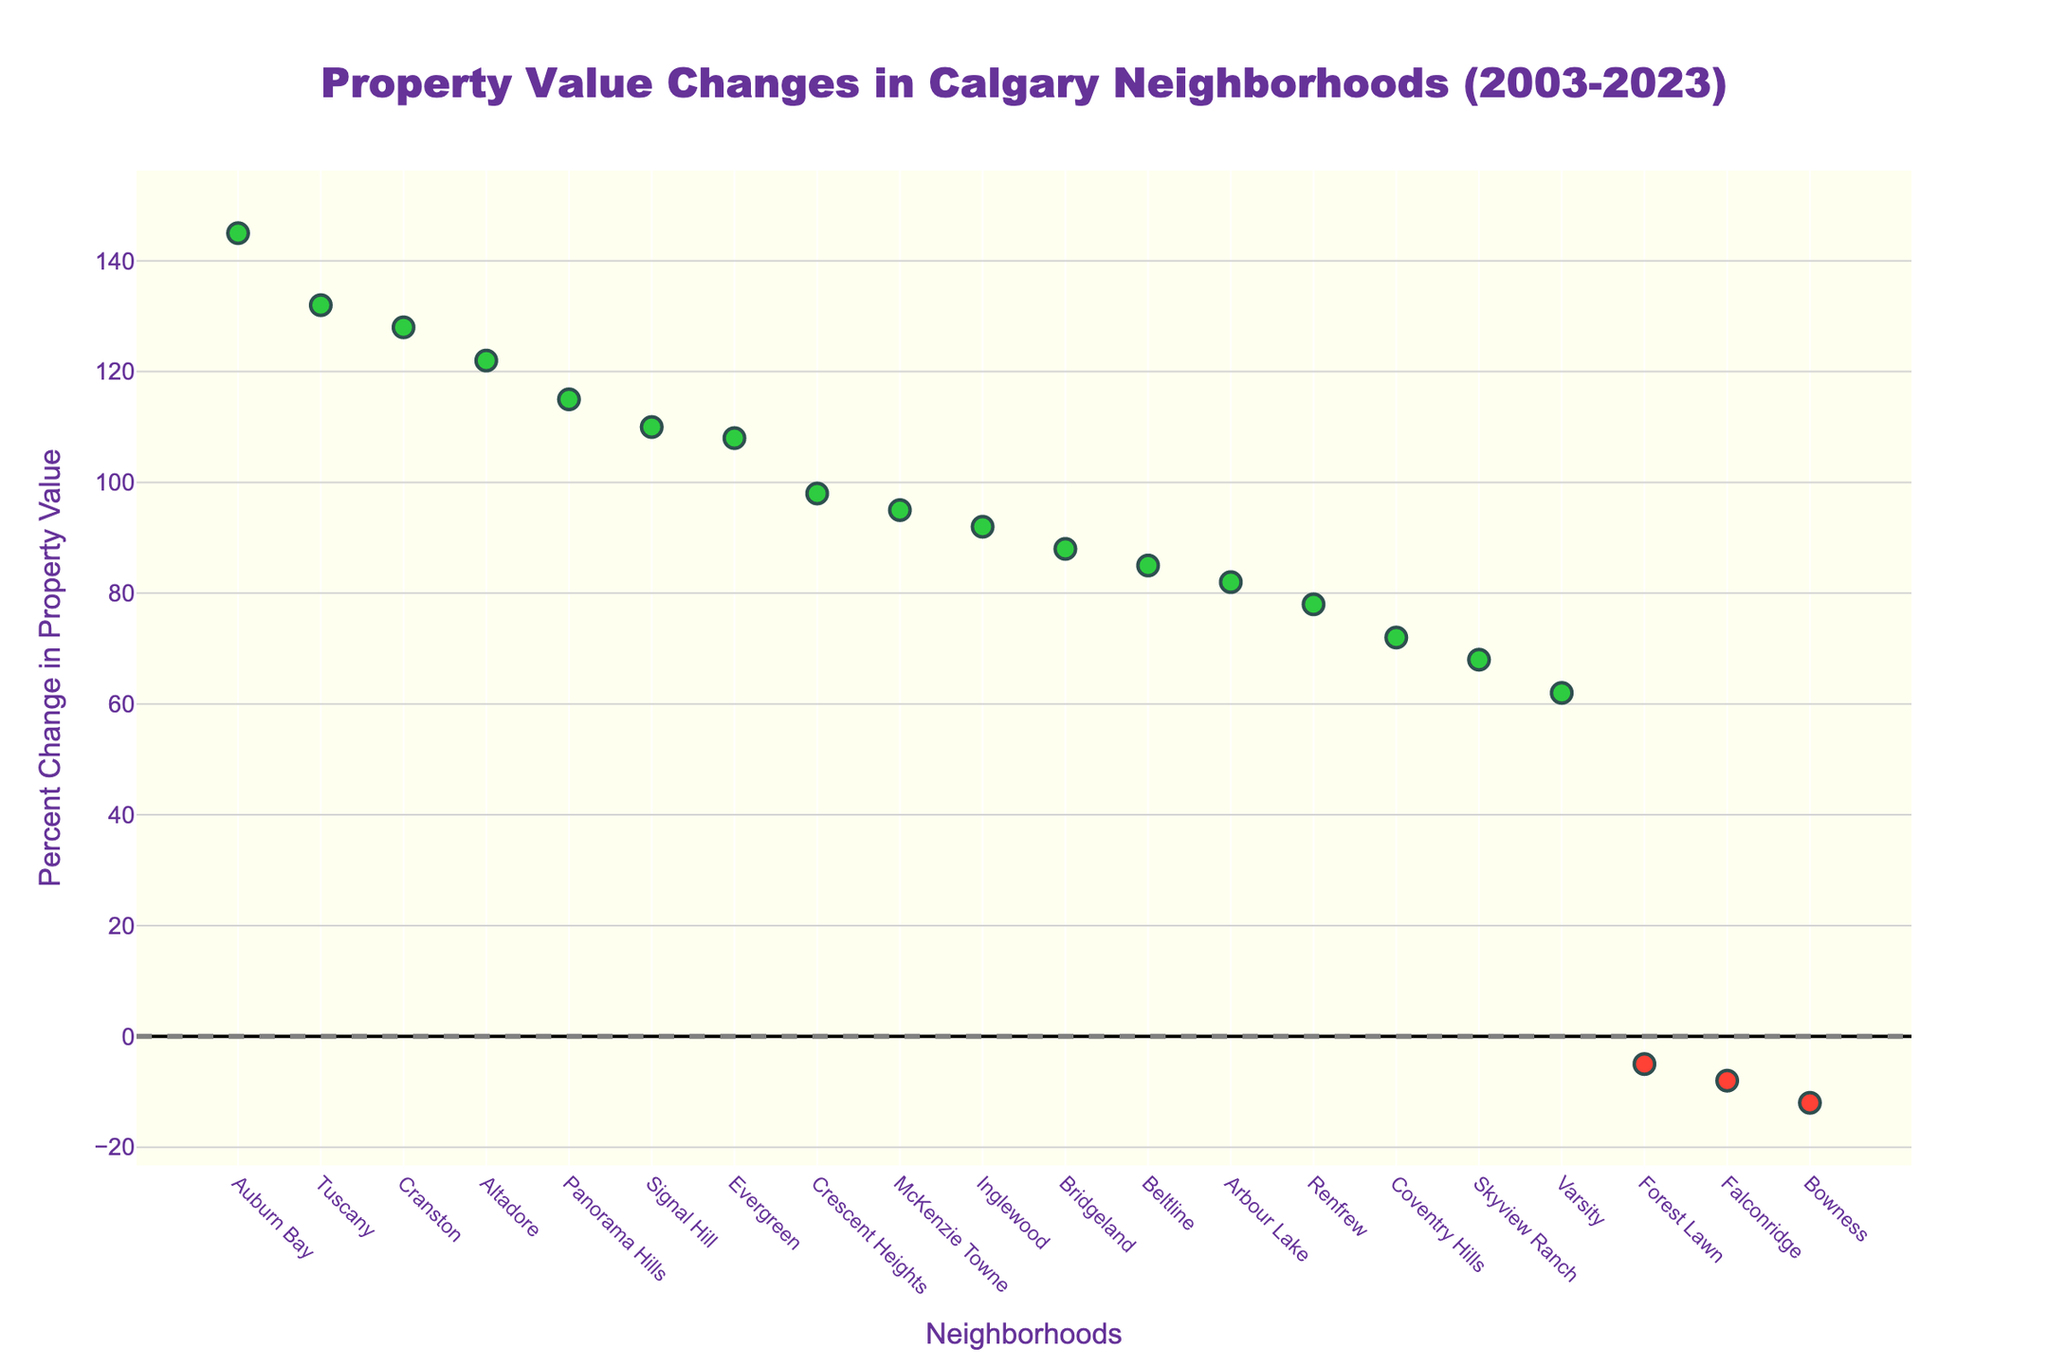What is the title of the figure? The title of the figure can be found at the top, centered above the chart.
Answer: Property Value Changes in Calgary Neighborhoods (2003-2023) Which neighborhood had the largest increase in property value percent change? The neighborhood with the highest point on the y-axis represents the largest increase.
Answer: Auburn Bay Which neighborhoods experienced a decrease in property value? The neighborhoods with their markers below the reference line at y = 0 indicate a decrease in property value. These include markers in red color.
Answer: Bowness, Forest Lawn, Falconridge How many neighborhoods are shown in the figure? Count the number of unique markers or the number of labels along the x-axis.
Answer: 20 What is the percent change for Beltline? Look for the marker labeled Beltline and read its y-axis value.
Answer: 85 Which neighborhood had a percent change closest to 100? Look for the marker closest to the y-axis value of 100 and check its label.
Answer: Crescent Heights What is the approximate difference in percent change between Signal Hill and Varsity? Identify the y-axis values for both neighborhoods and subtract the smaller from the larger. Signal Hill (110) - Varsity (62).
Answer: 48 Which neighborhood experienced the smallest change in property value percent change? Find the marker closest to the y-axis value of 0.
Answer: Forest Lawn What is the average percent change of neighborhoods with an increase in property value? Sum the y-axis values of all markers above the reference line at y=0, then divide by the number of these markers. (85+110+78+132+145+128+92+95+115+88+72+108+62+98+122+68+82)/17.
Answer: 97.7 How many neighborhoods have experienced at least a 100% increase in property value? Count the number of markers with a y-axis value greater than or equal to 100.
Answer: 7 